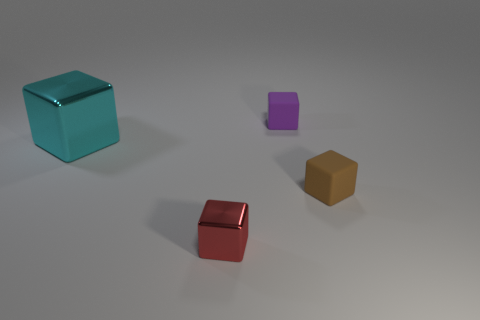Add 4 shiny cubes. How many objects exist? 8 Subtract all small gray balls. Subtract all brown rubber things. How many objects are left? 3 Add 1 cyan objects. How many cyan objects are left? 2 Add 4 yellow cylinders. How many yellow cylinders exist? 4 Subtract 1 red blocks. How many objects are left? 3 